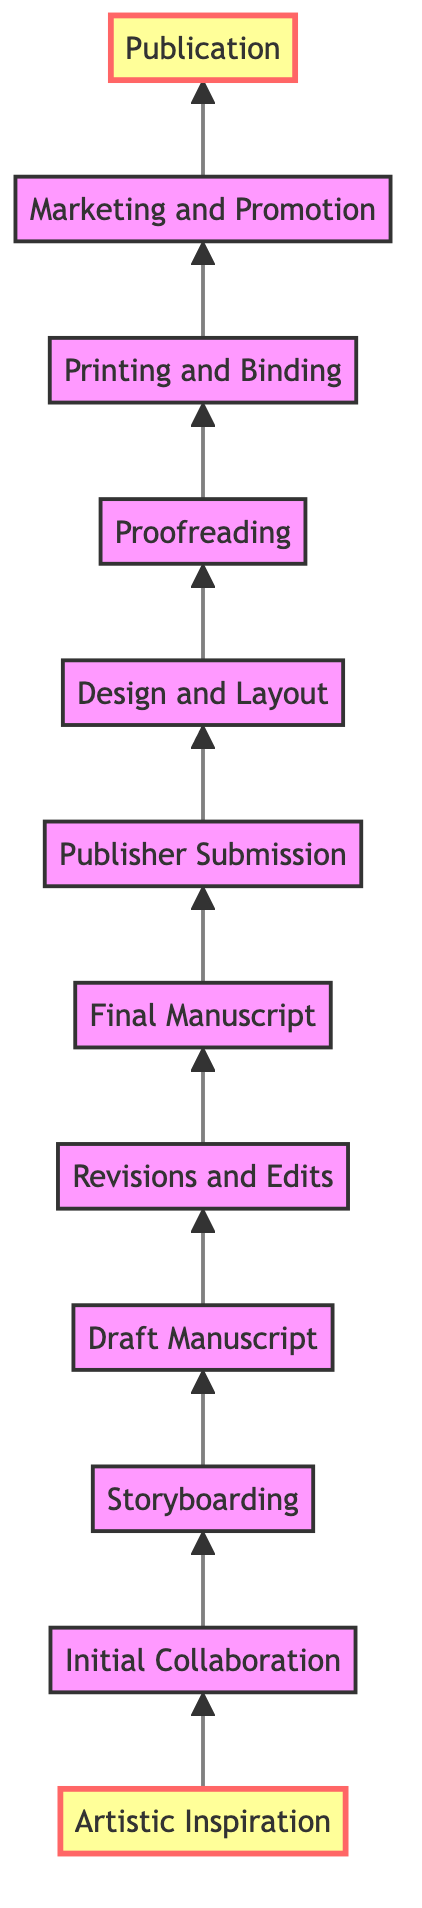What is the first step in the collaborative book journey? The first step indicated in the diagram is "Artistic Inspiration," which is where brainstorming sessions take place.
Answer: Artistic Inspiration How many total steps are there in the diagram? The diagram includes 12 distinct steps, beginning with "Artistic Inspiration" and ending with "Publication."
Answer: 12 What is the last step before "Publication"? The last step before "Publication" is "Marketing and Promotion," which develops the strategy for releasing the book.
Answer: Marketing and Promotion What activity follows "Draft Manuscript"? According to the flow, the activity that follows "Draft Manuscript" is "Revisions and Edits," indicating it's a critical next phase.
Answer: Revisions and Edits Which two nodes are directly connected to "Publisher Submission"? "Publisher Submission" is directly connected to "Final Manuscript" as the preceding step and "Design and Layout" as the subsequent step.
Answer: Final Manuscript, Design and Layout What is the role of "Design and Layout" in the publication process? "Design and Layout" involves collaborating with the publisher's design team to incorporate paintings into the book layout, essential for visual alignment.
Answer: Collaborating with the design team What is the significance of "Proofreading" in the process? "Proofreading" is crucial as it is the final check for textual errors and ensures that the placement of paintings is correct, affecting the overall quality.
Answer: Final check for errors Which two stages are highlighted in the diagram? The stages that are highlighted in the diagram are "Artistic Inspiration" and "Publication," marking key points in the journey.
Answer: Artistic Inspiration, Publication What does the flow of the diagram indicate about the collaboration direction? The flow of the diagram indicates a bottom-to-top direction, showing a progression from initial concepts to final publication, representing the timeline of collaboration.
Answer: Bottom-to-top progression What is the main focus during the "Initial Collaboration" phase? The main focus during "Initial Collaboration" is on discussing the themes, characters, and plots that are inspired by the artist's paintings.
Answer: Discussing themes and plots 